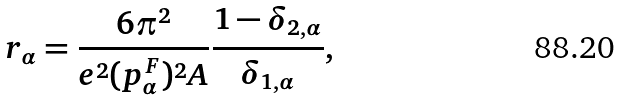<formula> <loc_0><loc_0><loc_500><loc_500>r _ { \alpha } = \frac { 6 \pi ^ { 2 } } { e ^ { 2 } ( p _ { \alpha } ^ { F } ) ^ { 2 } A } \frac { 1 - \delta _ { 2 , \alpha } } { \delta _ { 1 , \alpha } } ,</formula> 